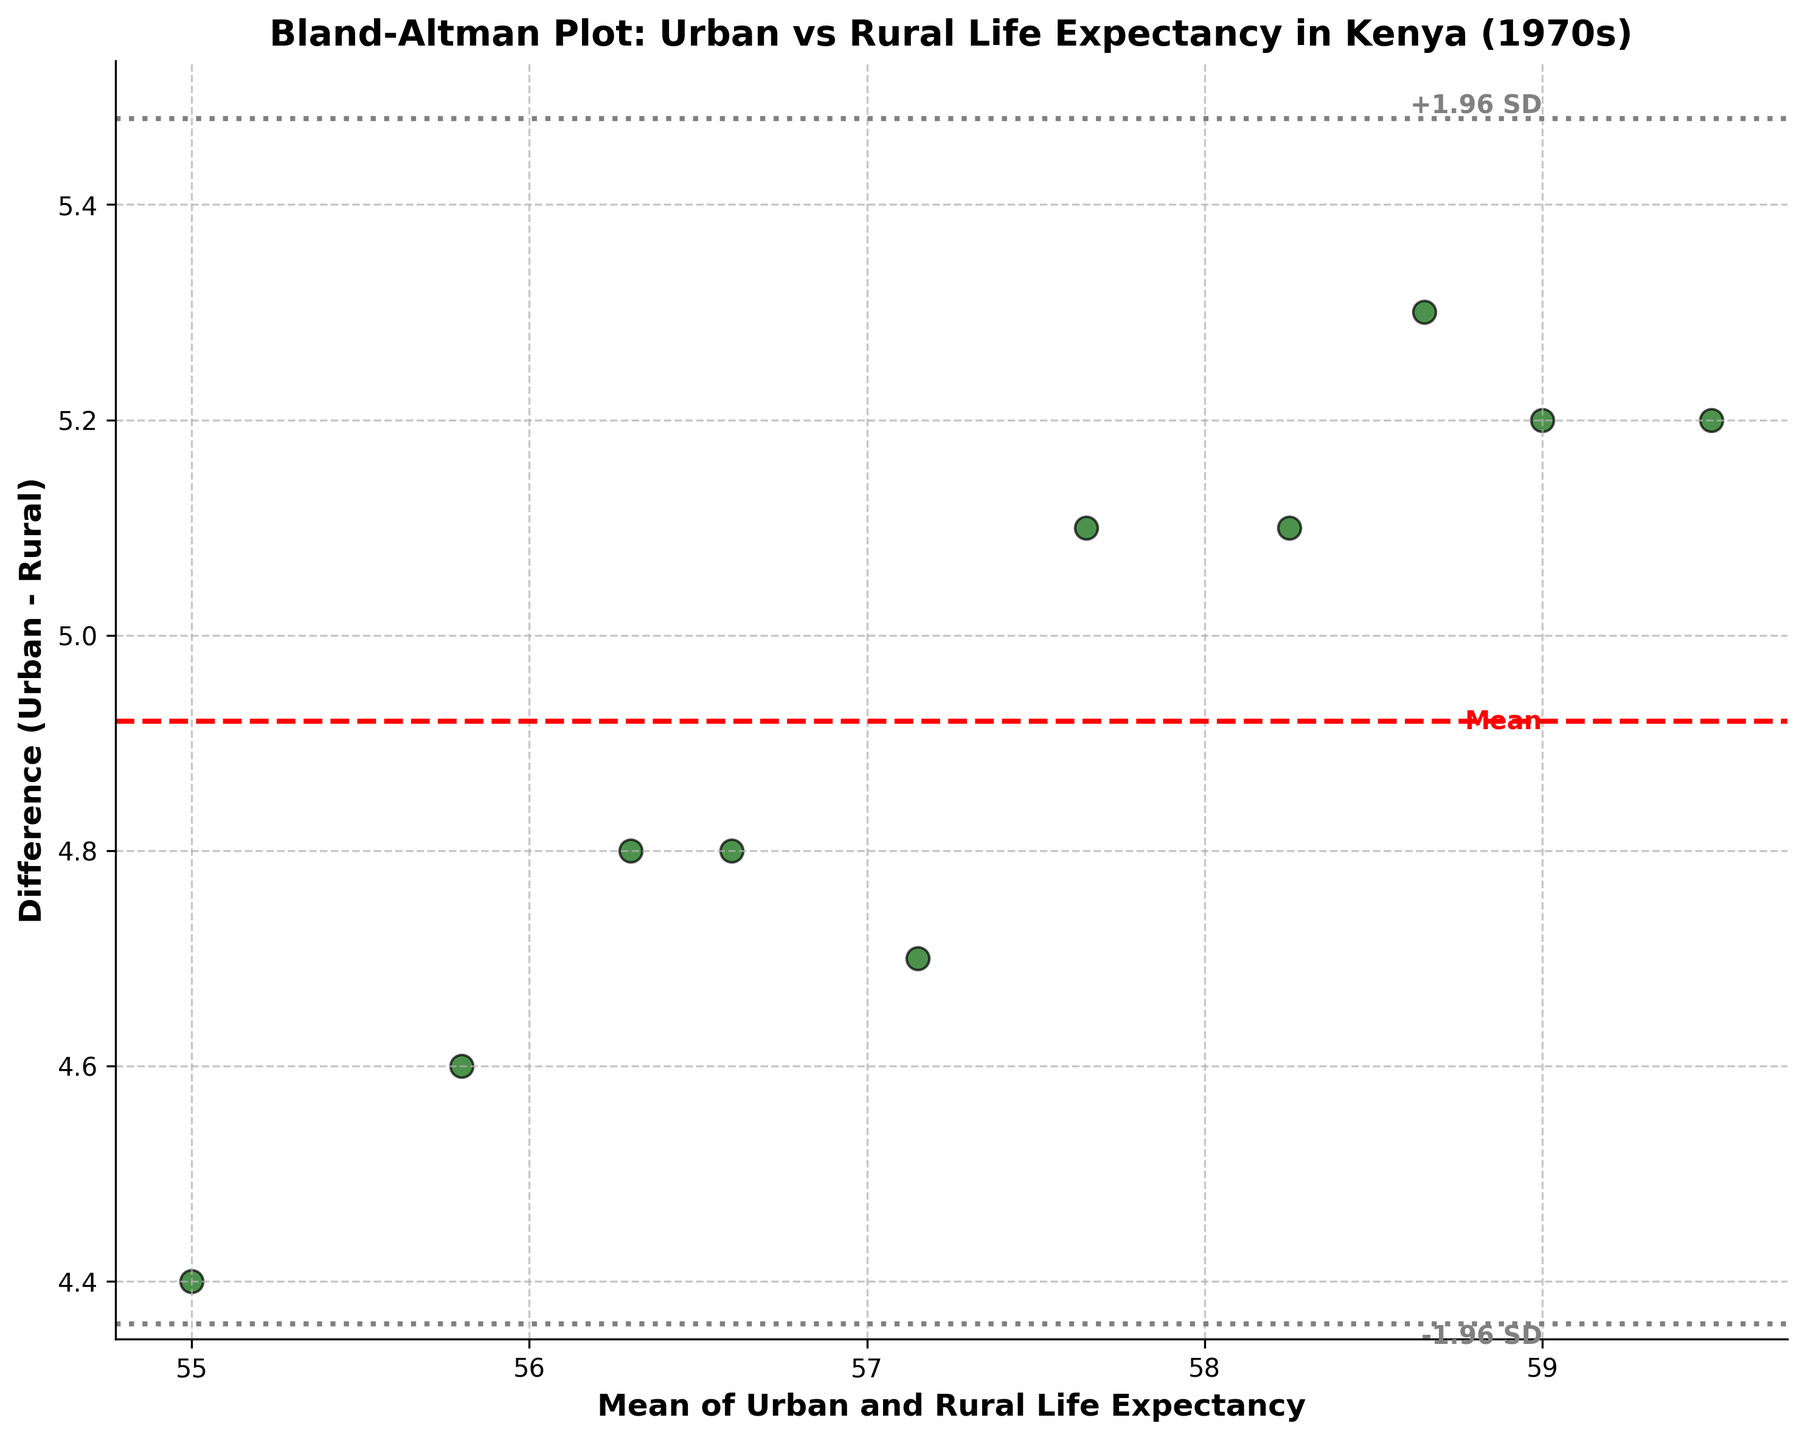What's the title of the plot? The title is displayed at the top of the figure in bold text.
Answer: Bland-Altman Plot: Urban vs Rural Life Expectancy in Kenya (1970s) What do the x and y axes represent? The x-axis represents the mean of Urban and Rural life expectancy, and the y-axis represents the difference between Urban and Rural life expectancy (Urban - Rural). This is written along the respective axes.
Answer: The mean of Urban and Rural Life Expectancy; Difference (Urban - Rural) How many data points are plotted on the graph? The data points appear as dark green dots with black edges. By counting them, we can see there are 10 in total.
Answer: 10 What is the mean difference between Urban and Rural life expectancy? The mean difference is indicated by a red dashed line on the y-axis, with the label "Mean" next to it.
Answer: 4.92 What's the upper limit of agreement (mean difference + 1.96*SD)? This limit is indicated by a gray dotted line above the mean line, with the label "+1.96 SD" next to it.
Answer: Approximately 5.9 What's the lower limit of agreement (mean difference - 1.96*SD)? This limit is shown by a gray dotted line below the mean line, with the label "-1.96 SD" next to it.
Answer: Approximately 3.94 Which point has the highest average life expectancy? From the scatter points, the highest point on the x-axis indicates the highest average life expectancy. This point corresponds to the data where the average is 59.5.
Answer: 59.5 What is the standard deviation of the differences? The upper limit of agreement can be found using the formula: mean difference + 1.96*SD. Rearranging to solve for SD and using approximate values: 5.9 = 4.92 + 1.96*SD, gives SD ≈ (5.9 - 4.92) / 1.96 ≈ 0.5.
Answer: 0.5 At what mean value does the largest difference occur? By looking at the highest point on the y-axis, we see that the corresponding mean value on the x-axis is closest to 58.65.
Answer: 58.65 